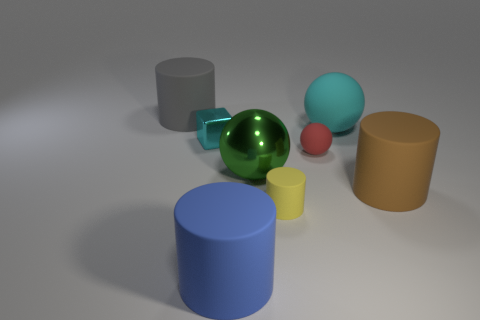Subtract all large cyan matte spheres. How many spheres are left? 2 Subtract all green balls. How many balls are left? 2 Subtract all cubes. How many objects are left? 7 Add 2 blue metal objects. How many objects exist? 10 Subtract 4 cylinders. How many cylinders are left? 0 Subtract all purple cylinders. How many blue spheres are left? 0 Subtract all tiny yellow matte things. Subtract all tiny rubber balls. How many objects are left? 6 Add 7 small cyan shiny blocks. How many small cyan shiny blocks are left? 8 Add 3 big cyan spheres. How many big cyan spheres exist? 4 Subtract 0 red cylinders. How many objects are left? 8 